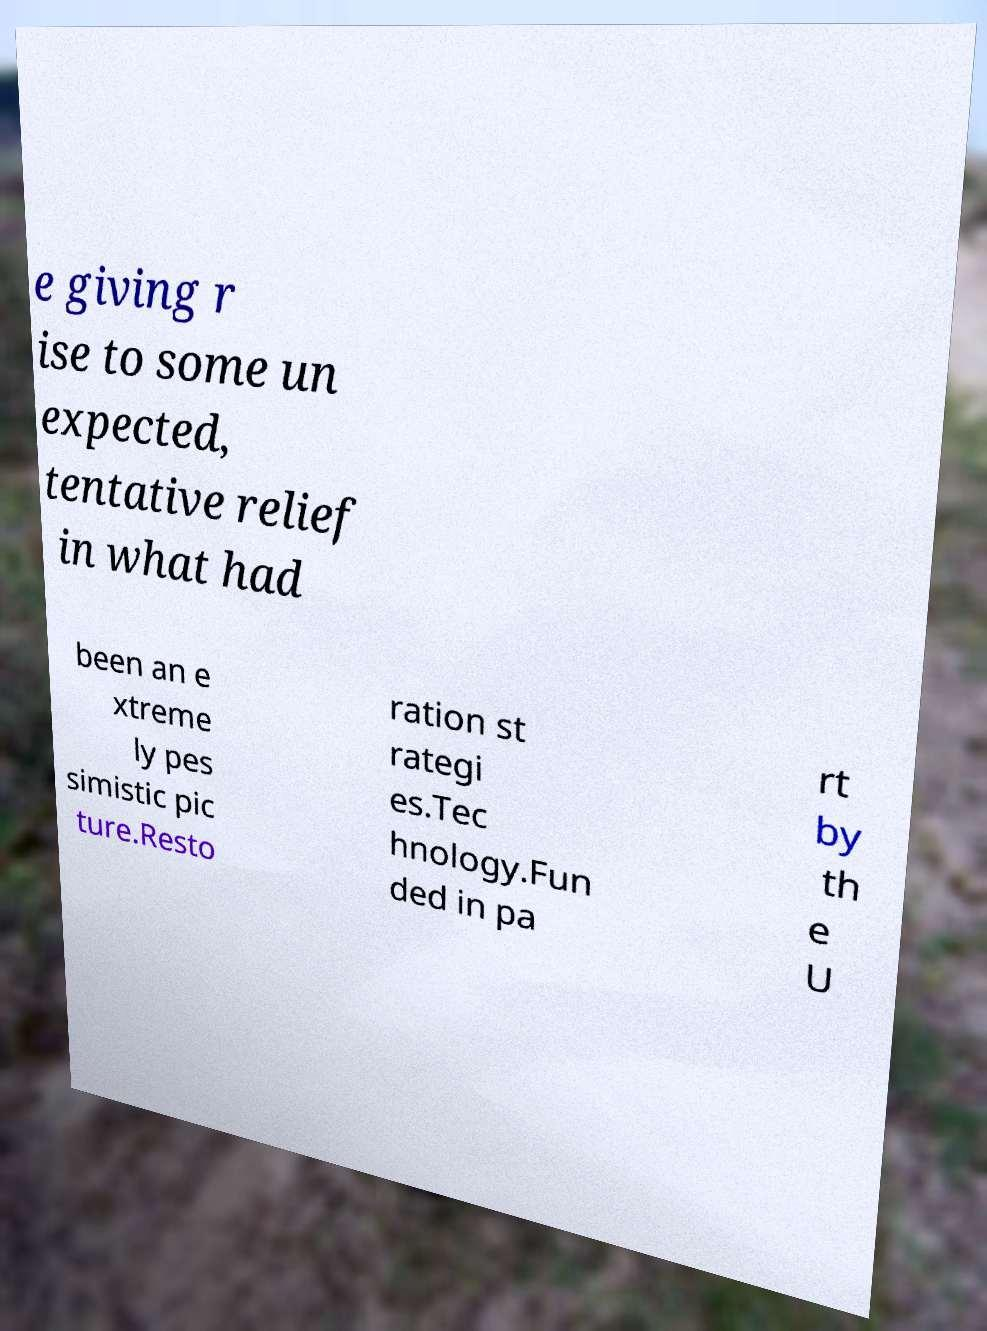What messages or text are displayed in this image? I need them in a readable, typed format. e giving r ise to some un expected, tentative relief in what had been an e xtreme ly pes simistic pic ture.Resto ration st rategi es.Tec hnology.Fun ded in pa rt by th e U 